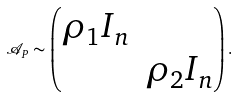Convert formula to latex. <formula><loc_0><loc_0><loc_500><loc_500>\mathcal { A } _ { P } \sim \begin{pmatrix} \rho _ { 1 } I _ { n } & \\ & \rho _ { 2 } I _ { n } \end{pmatrix} .</formula> 